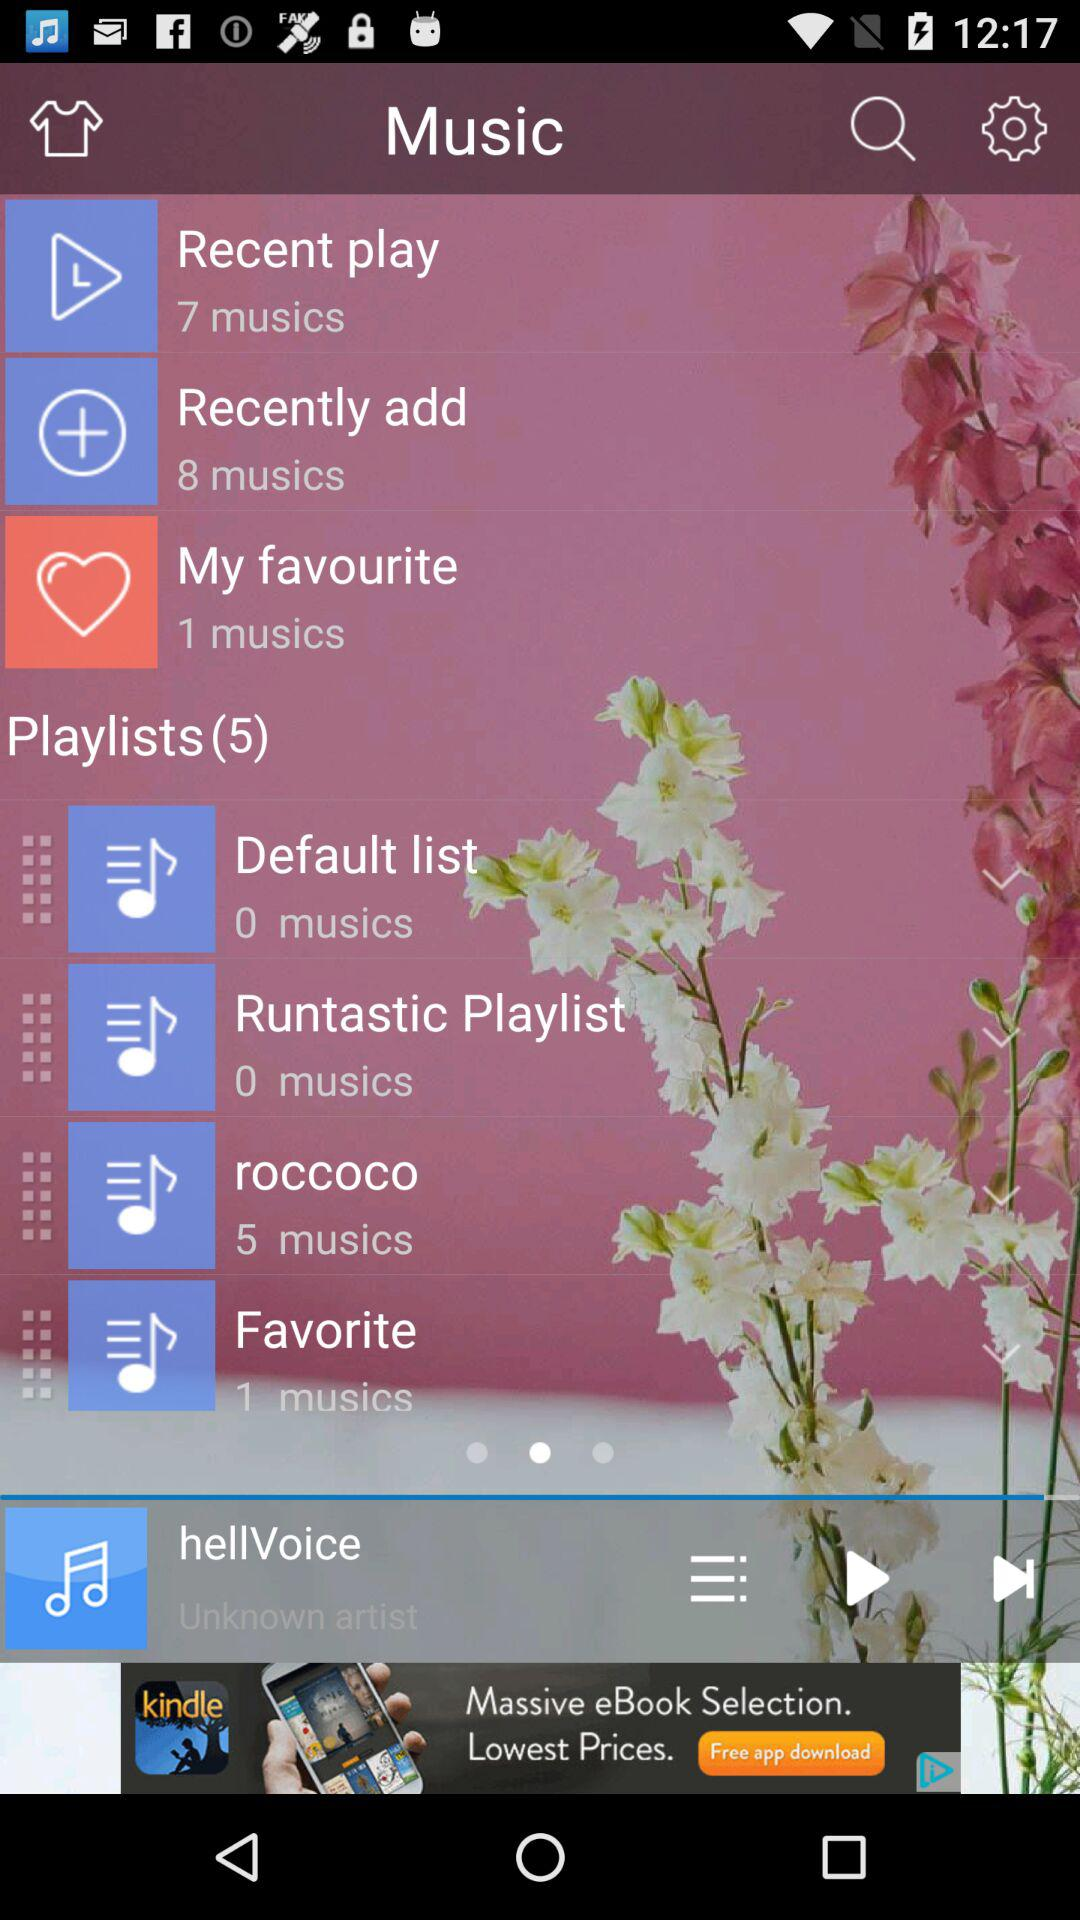What is the total number of music's in the roccoco? The total number of music's is 5. 